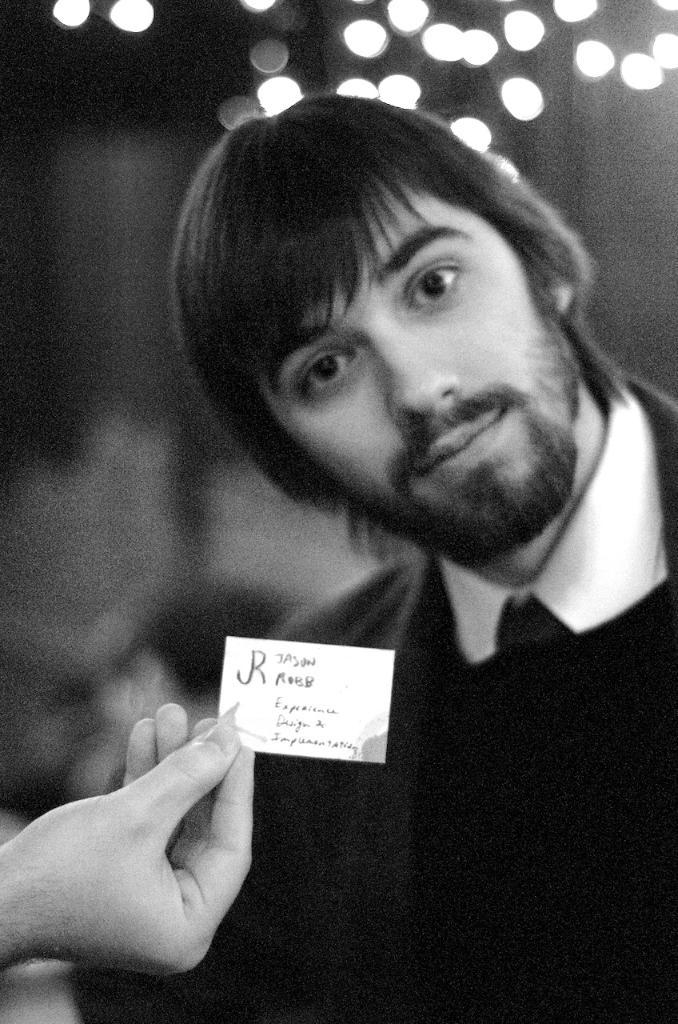Who is the main subject in the image? There is a man in the middle of the image. What is the man holding in the image? The man is not holding anything in the image. What can be seen on the left side bottom of the image? There is a hand holding a paper on the left side bottom of the image. What is the color scheme of the image? The image is black and white. What type of bat is flying in the image? There is no bat present in the image; it is a black and white image of a man and a hand holding a paper. 